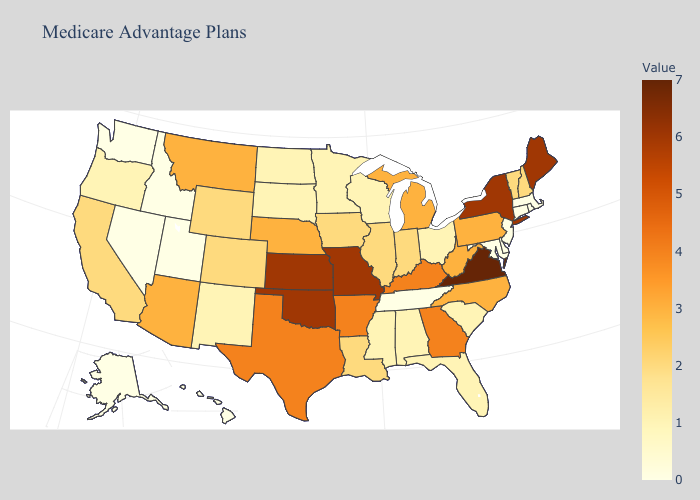Which states have the highest value in the USA?
Give a very brief answer. Virginia. Does Iowa have the highest value in the MidWest?
Answer briefly. No. Is the legend a continuous bar?
Short answer required. Yes. Does Massachusetts have the lowest value in the Northeast?
Give a very brief answer. Yes. Among the states that border Connecticut , does New York have the lowest value?
Answer briefly. No. Which states have the lowest value in the USA?
Give a very brief answer. Alaska, Connecticut, Delaware, Hawaii, Idaho, Massachusetts, Maryland, New Jersey, Nevada, Rhode Island, Tennessee, Utah, Washington. Does Alaska have the lowest value in the USA?
Answer briefly. Yes. 